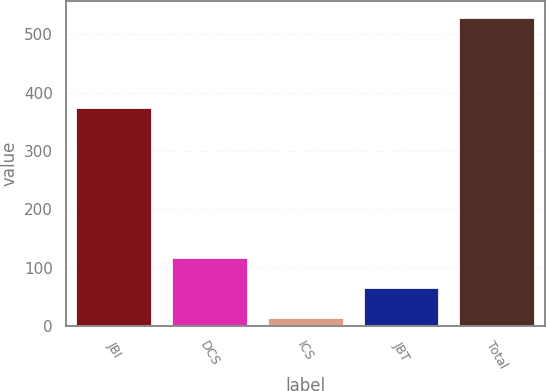Convert chart to OTSL. <chart><loc_0><loc_0><loc_500><loc_500><bar_chart><fcel>JBI<fcel>DCS<fcel>ICS<fcel>JBT<fcel>Total<nl><fcel>375<fcel>118.8<fcel>16<fcel>67.4<fcel>530<nl></chart> 